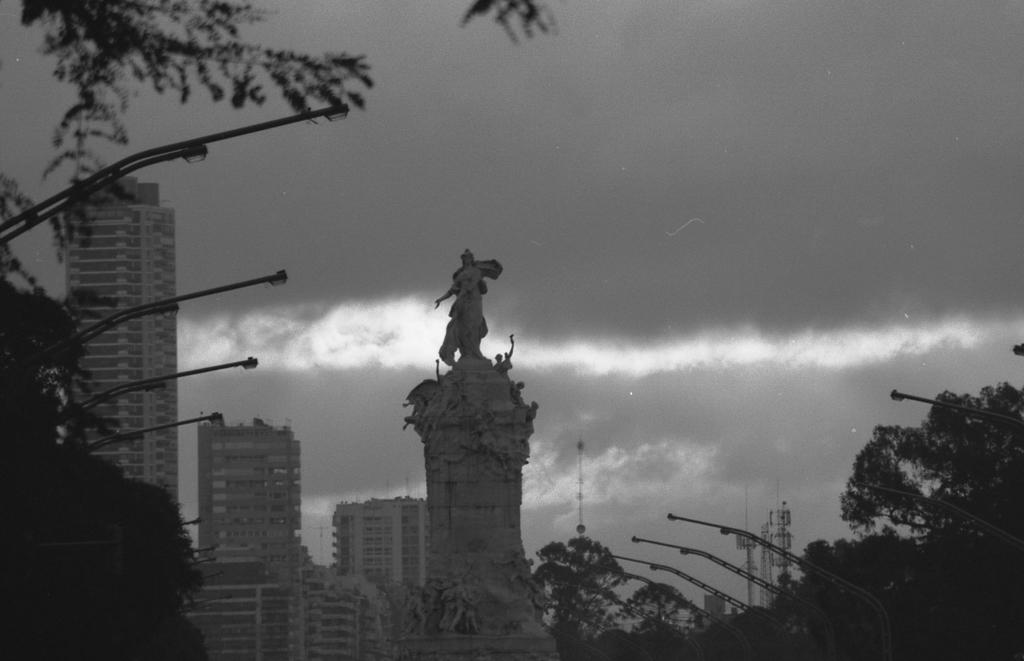What is the main subject in the center of the image? There is a statue in the center of the image. What can be seen in the background of the image? Buildings, street lights, trees, towers, and the sky are visible in the background of the image. Are there any clouds in the sky? Yes, clouds are present in the sky. Where is the family having a picnic in the image? There is no family having a picnic present in the image. What type of furniture can be seen in the bedroom in the image? There is no bedroom present in the image. 